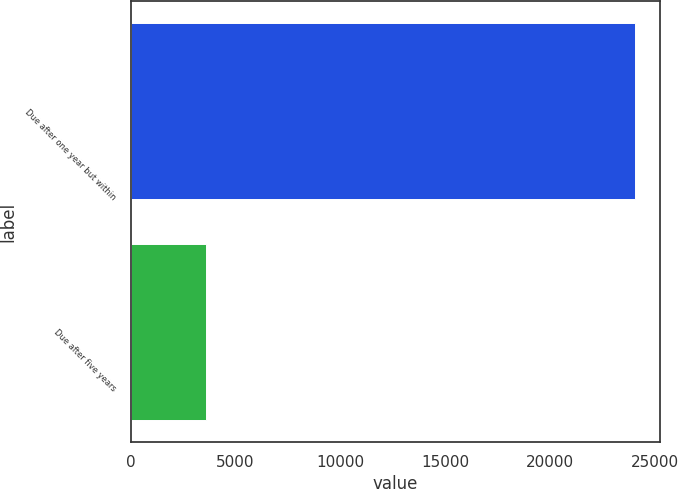<chart> <loc_0><loc_0><loc_500><loc_500><bar_chart><fcel>Due after one year but within<fcel>Due after five years<nl><fcel>24036<fcel>3585<nl></chart> 